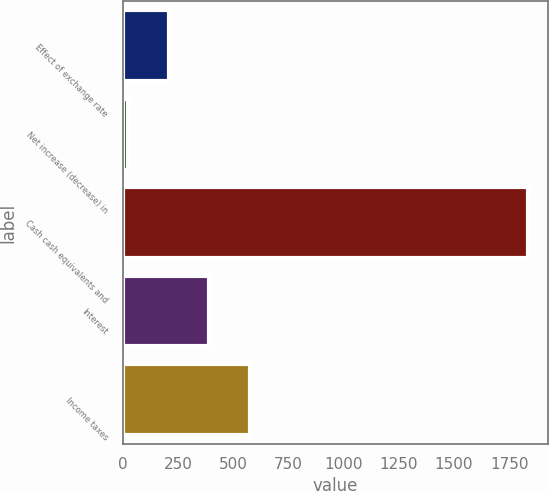<chart> <loc_0><loc_0><loc_500><loc_500><bar_chart><fcel>Effect of exchange rate<fcel>Net increase (decrease) in<fcel>Cash cash equivalents and<fcel>Interest<fcel>Income taxes<nl><fcel>208.5<fcel>25<fcel>1835<fcel>392<fcel>575.5<nl></chart> 